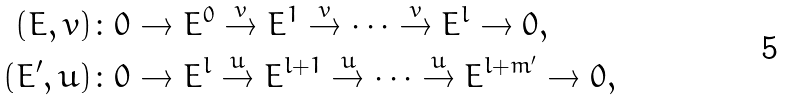<formula> <loc_0><loc_0><loc_500><loc_500>( E , v ) & \colon 0 \rightarrow E ^ { 0 } \overset { v } \rightarrow E ^ { 1 } \overset { v } \rightarrow \cdots \overset { v } \rightarrow E ^ { l } \rightarrow 0 , \\ ( E ^ { \prime } , u ) & \colon 0 \rightarrow E ^ { l } \overset { u } \rightarrow E ^ { l + 1 } \overset { u } \rightarrow \cdots \overset { u } \rightarrow E ^ { l + m ^ { \prime } } \rightarrow 0 ,</formula> 